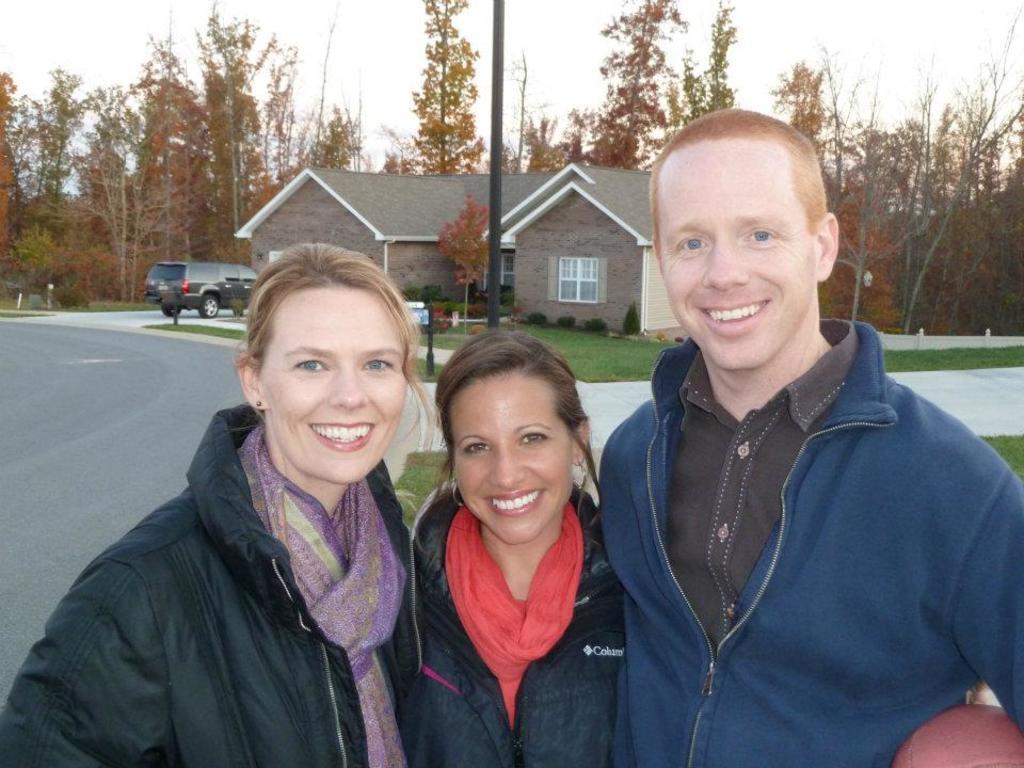Can you describe this image briefly? In the image there are three people standing and posing for the photo, they are smiling and behind them there are two houses, a vehicle, a pole and in the background there are many trees. 